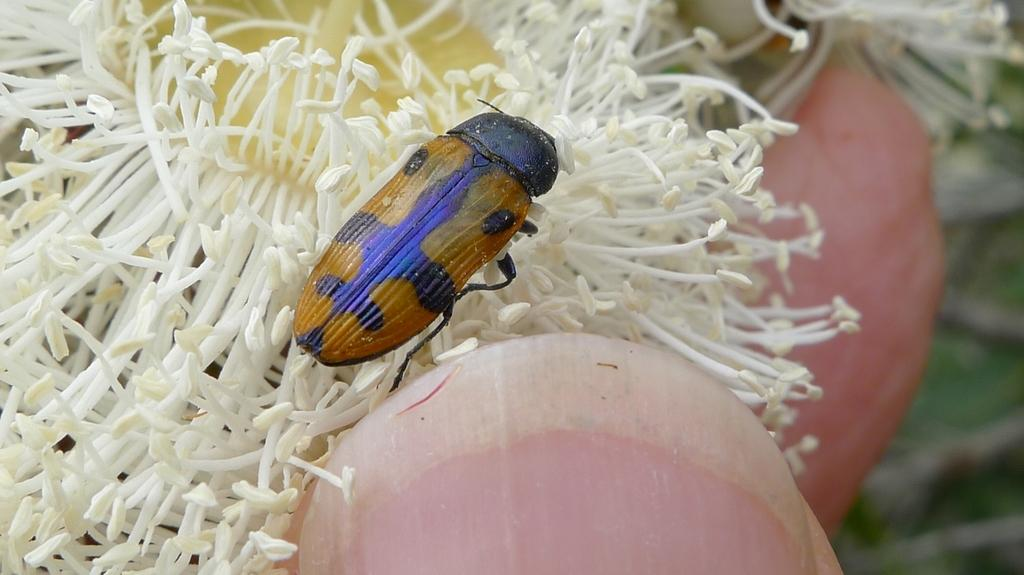What type of insect is in the image? There is a yellow and black insect in the image. What color are the objects in the image? The objects in the image are white. Can you describe a body part visible in the image? A person's nail is visible in the image. What language is the ant speaking in the image? There is no ant present in the image, and insects do not speak languages. 